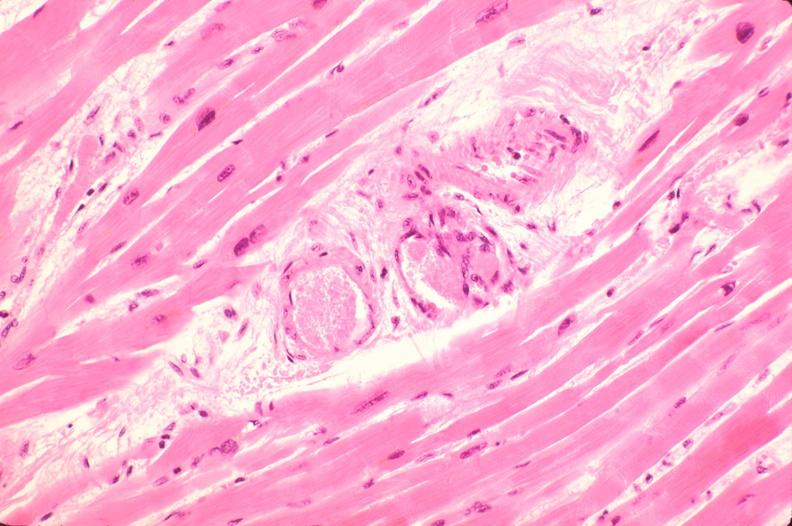does acid show heart, microthrombi, thrombotic thrombocytopenic purpura?
Answer the question using a single word or phrase. No 